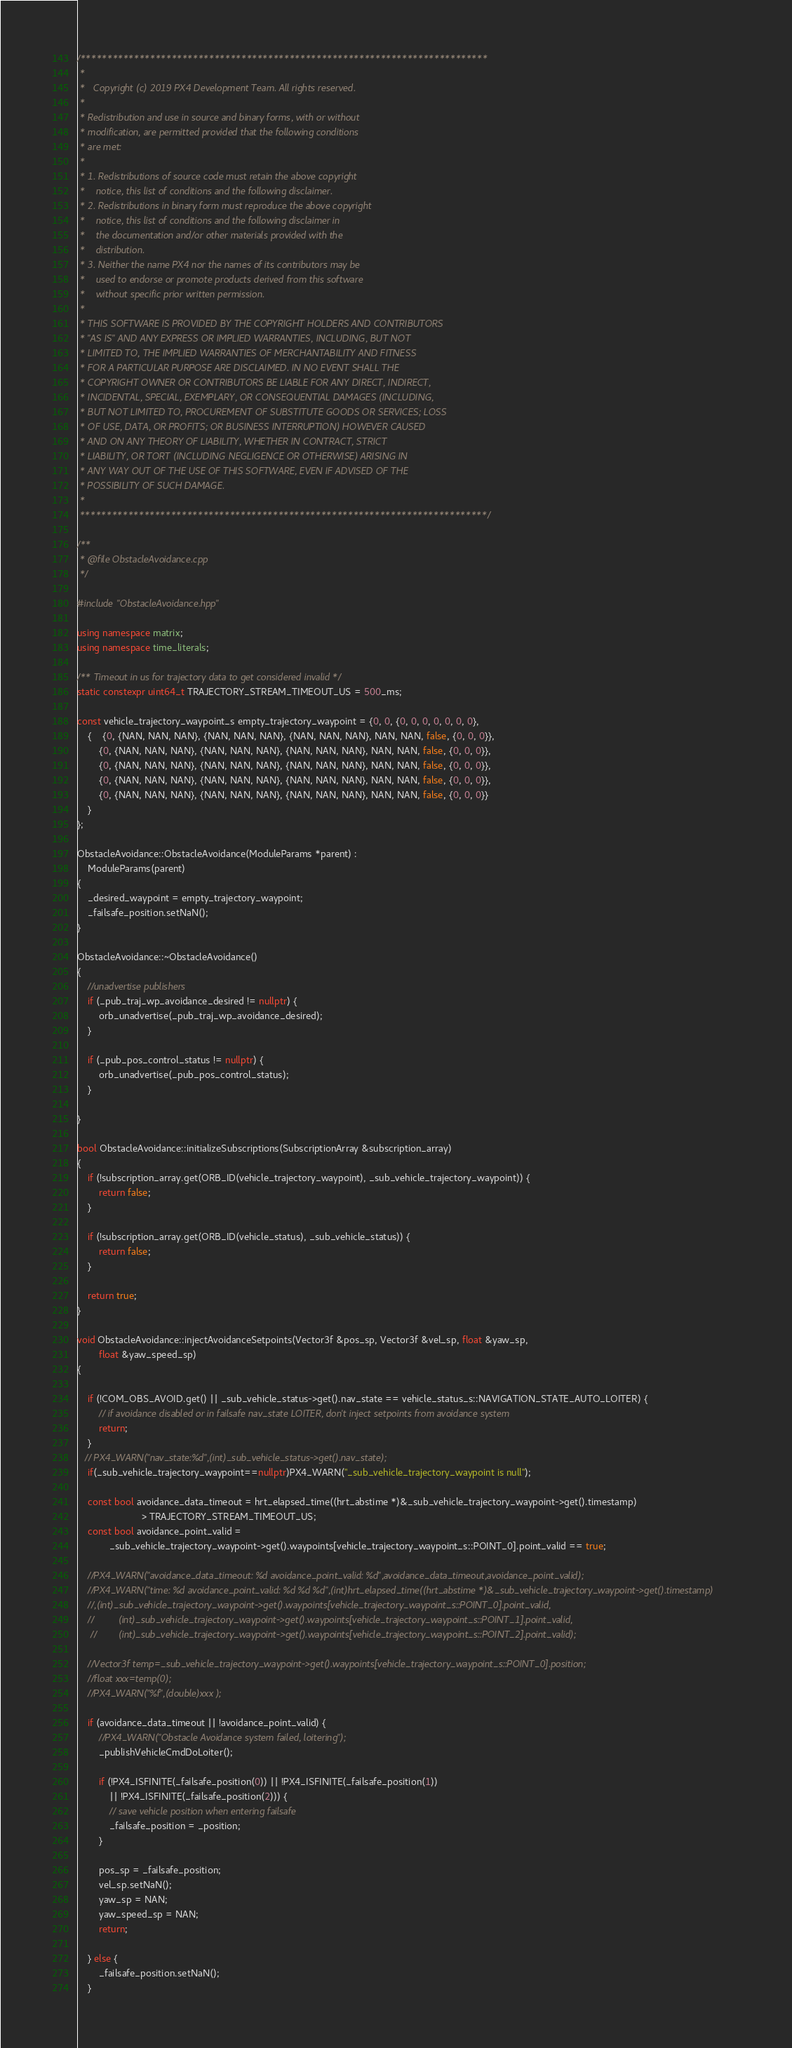<code> <loc_0><loc_0><loc_500><loc_500><_C++_>/****************************************************************************
 *
 *   Copyright (c) 2019 PX4 Development Team. All rights reserved.
 *
 * Redistribution and use in source and binary forms, with or without
 * modification, are permitted provided that the following conditions
 * are met:
 *
 * 1. Redistributions of source code must retain the above copyright
 *    notice, this list of conditions and the following disclaimer.
 * 2. Redistributions in binary form must reproduce the above copyright
 *    notice, this list of conditions and the following disclaimer in
 *    the documentation and/or other materials provided with the
 *    distribution.
 * 3. Neither the name PX4 nor the names of its contributors may be
 *    used to endorse or promote products derived from this software
 *    without specific prior written permission.
 *
 * THIS SOFTWARE IS PROVIDED BY THE COPYRIGHT HOLDERS AND CONTRIBUTORS
 * "AS IS" AND ANY EXPRESS OR IMPLIED WARRANTIES, INCLUDING, BUT NOT
 * LIMITED TO, THE IMPLIED WARRANTIES OF MERCHANTABILITY AND FITNESS
 * FOR A PARTICULAR PURPOSE ARE DISCLAIMED. IN NO EVENT SHALL THE
 * COPYRIGHT OWNER OR CONTRIBUTORS BE LIABLE FOR ANY DIRECT, INDIRECT,
 * INCIDENTAL, SPECIAL, EXEMPLARY, OR CONSEQUENTIAL DAMAGES (INCLUDING,
 * BUT NOT LIMITED TO, PROCUREMENT OF SUBSTITUTE GOODS OR SERVICES; LOSS
 * OF USE, DATA, OR PROFITS; OR BUSINESS INTERRUPTION) HOWEVER CAUSED
 * AND ON ANY THEORY OF LIABILITY, WHETHER IN CONTRACT, STRICT
 * LIABILITY, OR TORT (INCLUDING NEGLIGENCE OR OTHERWISE) ARISING IN
 * ANY WAY OUT OF THE USE OF THIS SOFTWARE, EVEN IF ADVISED OF THE
 * POSSIBILITY OF SUCH DAMAGE.
 *
 ****************************************************************************/

/**
 * @file ObstacleAvoidance.cpp
 */

#include "ObstacleAvoidance.hpp"

using namespace matrix;
using namespace time_literals;

/** Timeout in us for trajectory data to get considered invalid */
static constexpr uint64_t TRAJECTORY_STREAM_TIMEOUT_US = 500_ms;

const vehicle_trajectory_waypoint_s empty_trajectory_waypoint = {0, 0, {0, 0, 0, 0, 0, 0, 0},
	{	{0, {NAN, NAN, NAN}, {NAN, NAN, NAN}, {NAN, NAN, NAN}, NAN, NAN, false, {0, 0, 0}},
		{0, {NAN, NAN, NAN}, {NAN, NAN, NAN}, {NAN, NAN, NAN}, NAN, NAN, false, {0, 0, 0}},
		{0, {NAN, NAN, NAN}, {NAN, NAN, NAN}, {NAN, NAN, NAN}, NAN, NAN, false, {0, 0, 0}},
		{0, {NAN, NAN, NAN}, {NAN, NAN, NAN}, {NAN, NAN, NAN}, NAN, NAN, false, {0, 0, 0}},
		{0, {NAN, NAN, NAN}, {NAN, NAN, NAN}, {NAN, NAN, NAN}, NAN, NAN, false, {0, 0, 0}}
	}
};

ObstacleAvoidance::ObstacleAvoidance(ModuleParams *parent) :
	ModuleParams(parent)
{
	_desired_waypoint = empty_trajectory_waypoint;
	_failsafe_position.setNaN();
}

ObstacleAvoidance::~ObstacleAvoidance()
{
	//unadvertise publishers
	if (_pub_traj_wp_avoidance_desired != nullptr) {
		orb_unadvertise(_pub_traj_wp_avoidance_desired);
	}

	if (_pub_pos_control_status != nullptr) {
		orb_unadvertise(_pub_pos_control_status);
	}

}

bool ObstacleAvoidance::initializeSubscriptions(SubscriptionArray &subscription_array)
{
	if (!subscription_array.get(ORB_ID(vehicle_trajectory_waypoint), _sub_vehicle_trajectory_waypoint)) {
		return false;
	}

	if (!subscription_array.get(ORB_ID(vehicle_status), _sub_vehicle_status)) {
		return false;
	}

	return true;
}

void ObstacleAvoidance::injectAvoidanceSetpoints(Vector3f &pos_sp, Vector3f &vel_sp, float &yaw_sp,
		float &yaw_speed_sp)
{

	if (!COM_OBS_AVOID.get() || _sub_vehicle_status->get().nav_state == vehicle_status_s::NAVIGATION_STATE_AUTO_LOITER) {
		// if avoidance disabled or in failsafe nav_state LOITER, don't inject setpoints from avoidance system
		return;
	}
   // PX4_WARN("nav_state:%d",(int)_sub_vehicle_status->get().nav_state);
	if(_sub_vehicle_trajectory_waypoint==nullptr)PX4_WARN("_sub_vehicle_trajectory_waypoint is null");

	const bool avoidance_data_timeout = hrt_elapsed_time((hrt_abstime *)&_sub_vehicle_trajectory_waypoint->get().timestamp)
					    > TRAJECTORY_STREAM_TIMEOUT_US;
    const bool avoidance_point_valid =
            _sub_vehicle_trajectory_waypoint->get().waypoints[vehicle_trajectory_waypoint_s::POINT_0].point_valid == true;

	//PX4_WARN("avoidance_data_timeout: %d avoidance_point_valid: %d",avoidance_data_timeout,avoidance_point_valid);
    //PX4_WARN("time: %d avoidance_point_valid: %d %d %d",(int)hrt_elapsed_time((hrt_abstime *)&_sub_vehicle_trajectory_waypoint->get().timestamp)
    //,(int)_sub_vehicle_trajectory_waypoint->get().waypoints[vehicle_trajectory_waypoint_s::POINT_0].point_valid,
    //         (int)_sub_vehicle_trajectory_waypoint->get().waypoints[vehicle_trajectory_waypoint_s::POINT_1].point_valid,
     //        (int)_sub_vehicle_trajectory_waypoint->get().waypoints[vehicle_trajectory_waypoint_s::POINT_2].point_valid);

    //Vector3f temp=_sub_vehicle_trajectory_waypoint->get().waypoints[vehicle_trajectory_waypoint_s::POINT_0].position;
    //float xxx=temp(0);
    //PX4_WARN("%f",(double)xxx );

    if (avoidance_data_timeout || !avoidance_point_valid) {
		//PX4_WARN("Obstacle Avoidance system failed, loitering");
		_publishVehicleCmdDoLoiter();

		if (!PX4_ISFINITE(_failsafe_position(0)) || !PX4_ISFINITE(_failsafe_position(1))
		    || !PX4_ISFINITE(_failsafe_position(2))) {
			// save vehicle position when entering failsafe
			_failsafe_position = _position;
		}

		pos_sp = _failsafe_position;
		vel_sp.setNaN();
		yaw_sp = NAN;
		yaw_speed_sp = NAN;
		return;

	} else {
		_failsafe_position.setNaN();
	}
</code> 